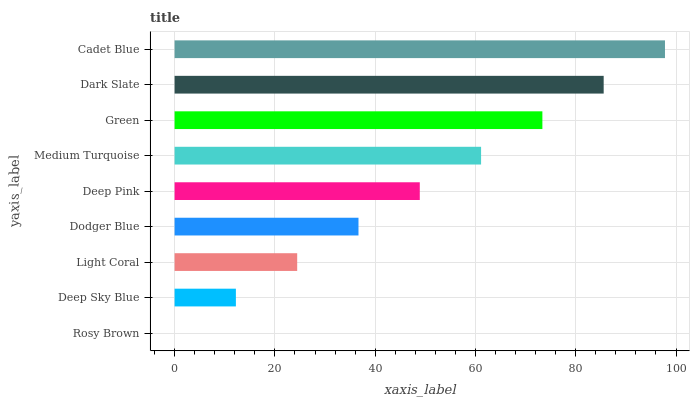Is Rosy Brown the minimum?
Answer yes or no. Yes. Is Cadet Blue the maximum?
Answer yes or no. Yes. Is Deep Sky Blue the minimum?
Answer yes or no. No. Is Deep Sky Blue the maximum?
Answer yes or no. No. Is Deep Sky Blue greater than Rosy Brown?
Answer yes or no. Yes. Is Rosy Brown less than Deep Sky Blue?
Answer yes or no. Yes. Is Rosy Brown greater than Deep Sky Blue?
Answer yes or no. No. Is Deep Sky Blue less than Rosy Brown?
Answer yes or no. No. Is Deep Pink the high median?
Answer yes or no. Yes. Is Deep Pink the low median?
Answer yes or no. Yes. Is Dodger Blue the high median?
Answer yes or no. No. Is Rosy Brown the low median?
Answer yes or no. No. 